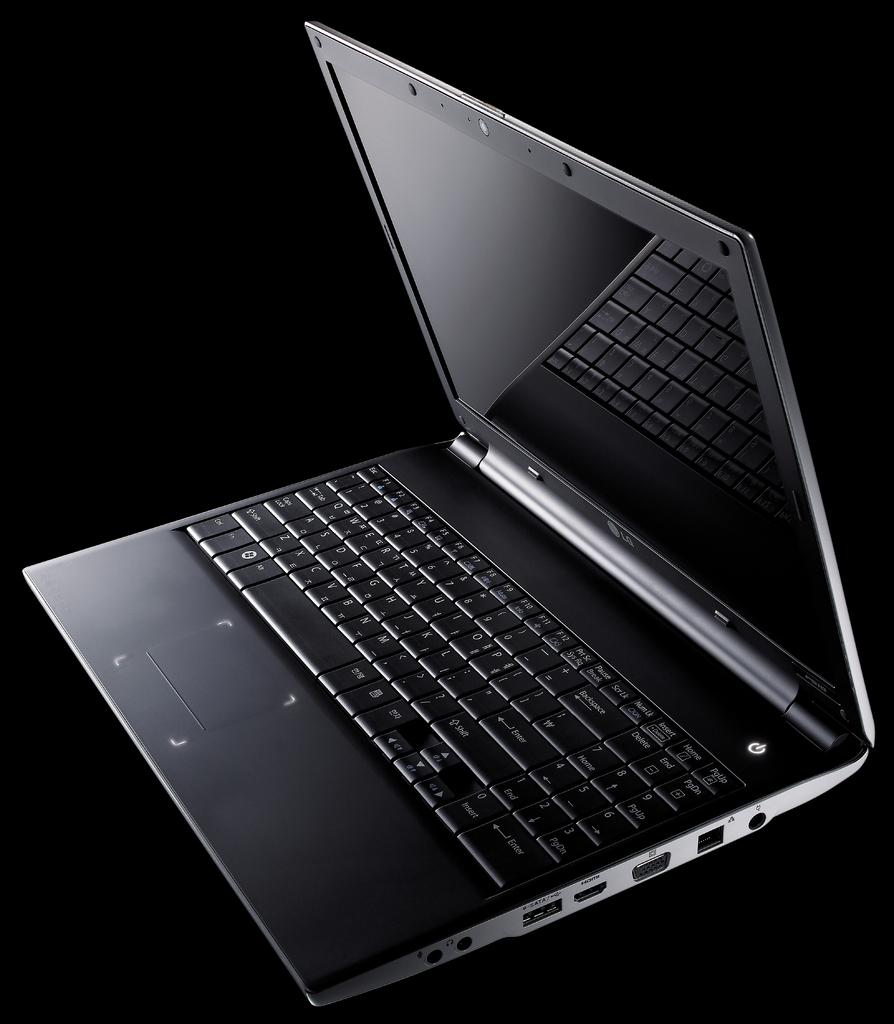<image>
Offer a succinct explanation of the picture presented. The LG laptop is on a black background. 